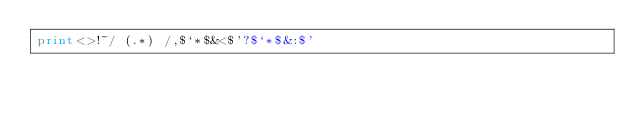Convert code to text. <code><loc_0><loc_0><loc_500><loc_500><_Perl_>print<>!~/ (.*) /,$`*$&<$'?$`*$&:$'</code> 